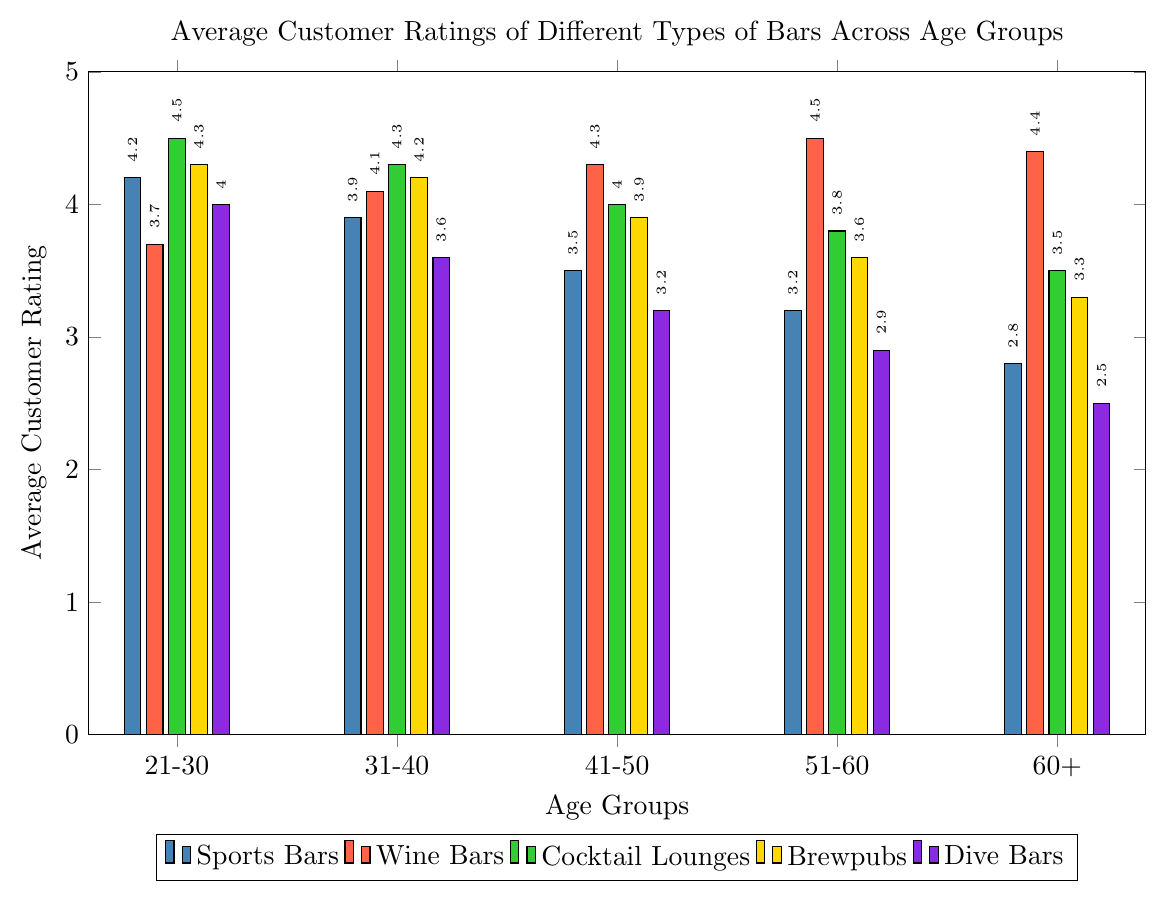Which bar type has the lowest average rating for the 60+ age group? Observe the ratings for the 60+ age group and find the smallest value among all bar types. The lowest rating here is for Dive Bars at 2.5.
Answer: Dive Bars Which age group has the highest rating for Rooftop Bars? Look for the highest rating in the sequence of ratings for Rooftop Bars across all the age groups. The highest rating is 4.6 for the 21-30 age group.
Answer: 21-30 Compare the rating trends for Sports Bars and Wine Bars across age groups. Observe and compare the pattern of ratings for both bar types from the youngest to the oldest age group. Sports Bars show a decreasing trend over the age groups, whereas Wine Bars show an increasing trend.
Answer: Sports Bars decrease, Wine Bars increase What is the average rating for Brewpubs across all age groups? Add all the ratings for Brewpubs and divide by the number of age groups. (4.3 + 4.2 + 3.9 + 3.6 + 3.3) / 5 = 19.3 / 5 = 3.86
Answer: 3.86 Which bar type has a consistent increase in ratings as the age group rises from 21-30 to 60+? For each bar type, check if the ratings strictly increase as the age groups progress from 21-30 to 60+. Wine Bars have ratings that consistently increase (3.7, 4.1, 4.3, 4.5, 4.4).
Answer: Wine Bars What bar type is visually represented by the color green? Identify the colored bar that corresponds to green and note the legend entry. Green color represents Cocktail Lounges.
Answer: Cocktail Lounges In which age group does Tiki Bars have a higher rating than Speakeasies? Compare the ratings for each age group between Tiki Bars and Speakeasies. Tiki Bars have higher ratings in these age groups: 21-30 (4.2 vs. 4.4), 31-40 (4.0 vs. 4.2) and 41-50 (3.7 vs. 3.9), it’s 3.5 vs. 3.4 in 51-60 and 3.2 vs. 3.4 in 60+.
Answer: None Which bar type has the highest overall rating irrespective of age groups? Identify the bar type with the highest rating seen in the entire chart. Rooftop Bars have the highest single rating of 4.6 for the 21-30 age group.
Answer: Rooftop Bars For the 31-40 age group, which two bar types have closest ratings? Calculate the differences between the ratings of all bars within the 31-40 age group. The closest ratings are for Irish Pubs and Dive Bars (4.0 - 3.6) = 0.4.
Answer: Irish Pubs and Dive Bars 